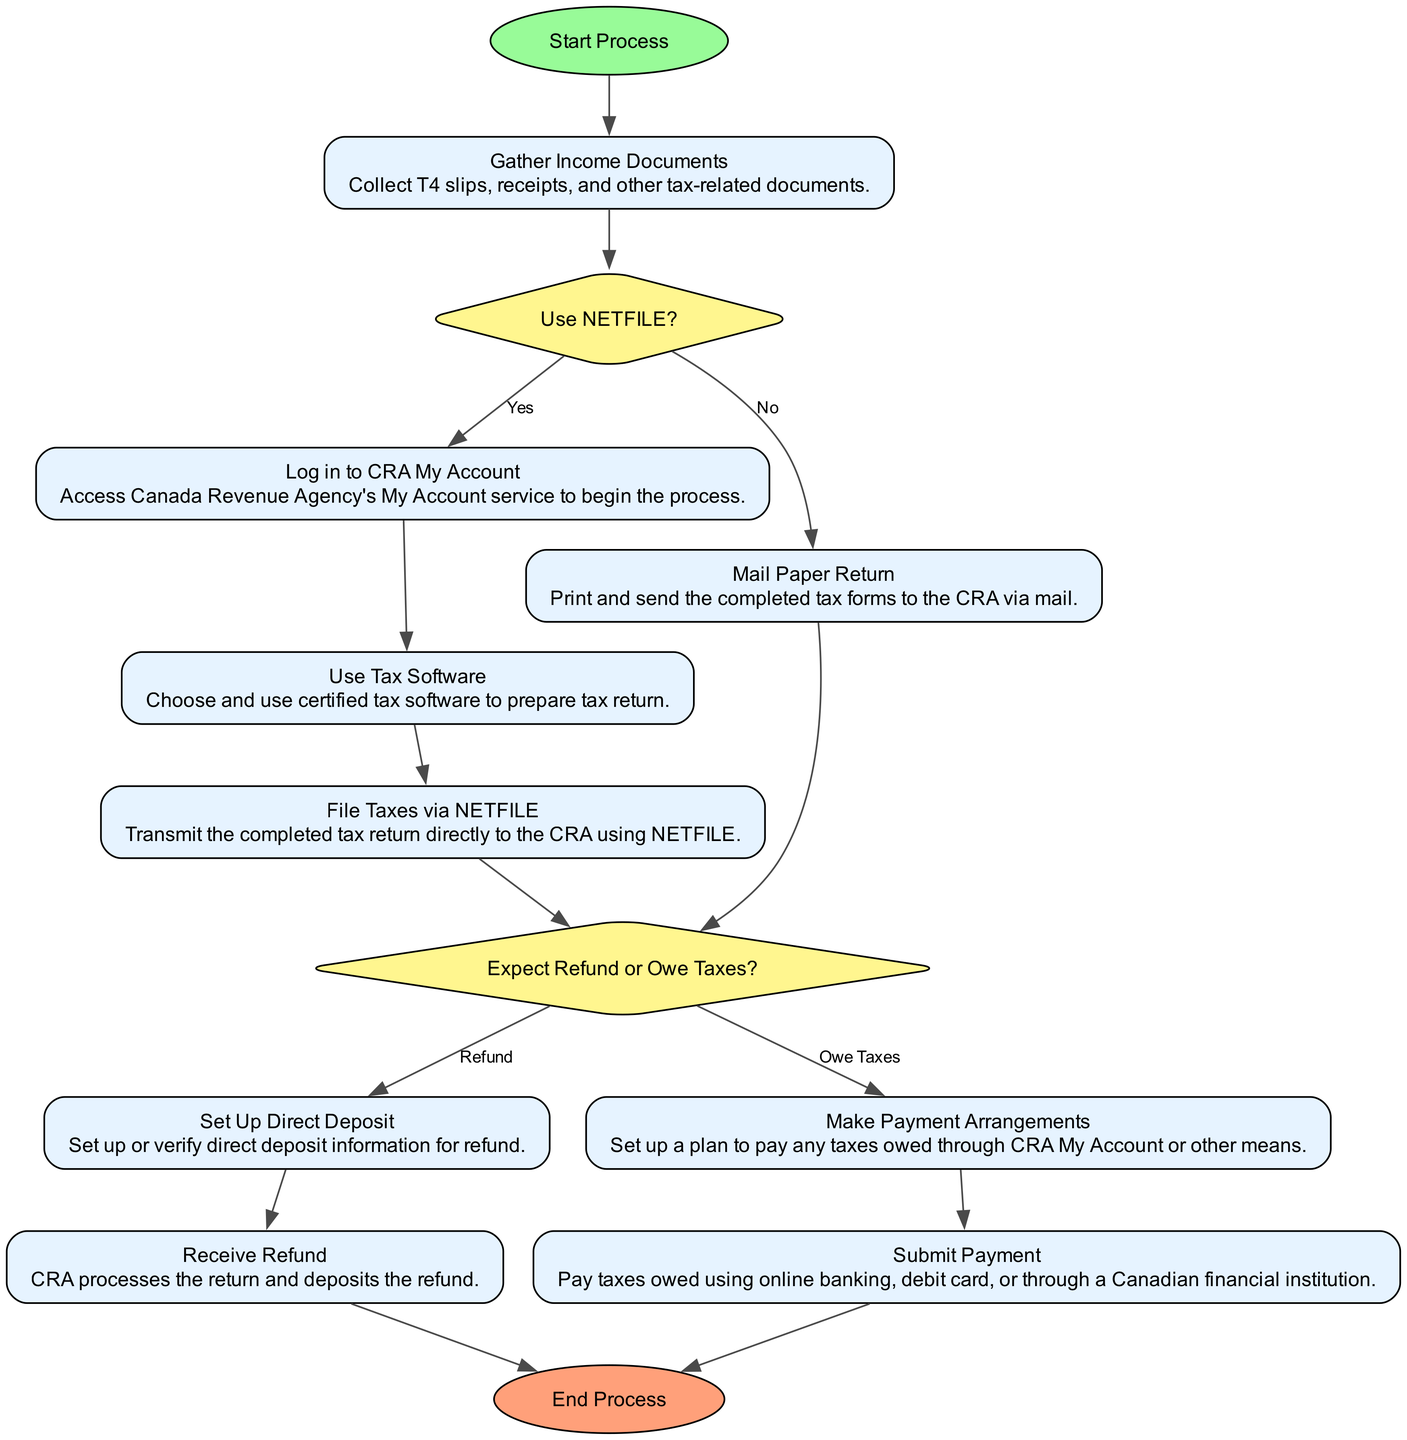What is the first activity in the process? The first activity, indicated right after the start, is "Gather Income Documents." This is the initial step required to begin filing taxes online.
Answer: Gather Income Documents How many decision nodes are present in the diagram? The diagram contains two decision nodes: "Use NETFILE?" and "Expect Refund or Owe Taxes?". Both are key decision points in the tax filing process.
Answer: 2 What action is taken if the answer to "Use NETFILE?" is "No"? If "Use NETFILE?" is answered with "No", the next action is "Mail Paper Return," which indicates that the taxpayer will mail their tax forms instead of filing online.
Answer: Mail Paper Return Which activity follows after logging into CRA My Account? After "Log in to CRA My Account," the subsequent activity is "Use Tax Software," where the taxpayer prepares their tax return using certified tax software.
Answer: Use Tax Software What is the outcome if taxes owed is indicated as "Refund"? If taxes owed is indicated as "Refund," the process moves to "Set Up Direct Deposit," where the taxpayer sets up or confirms their direct deposit information for receiving the refund.
Answer: Set Up Direct Deposit Which activity leads directly to the end of the process after receiving a refund? After "Receive Refund," the next step is directly connected to "End Process," completing the filing and payment cycle for income taxes.
Answer: End Process What is the final step for making payments if taxes are owed? If it is established that the taxpayer owes taxes, the final step for making payments is "Submit Payment," where the taxpayer pays any outstanding taxes due.
Answer: Submit Payment What type of software must be used for preparing the tax return? The diagram specifies that one must use "certified tax software" to prepare the tax return to ensure compliance and correctness in the submission.
Answer: Certified tax software Which node indicates the choice between receiving a refund or owing taxes? The node that indicates the choice between receiving a refund or owing taxes is "Expect Refund or Owe Taxes?" It assesses the tax return outcome and directs the next steps based on this decision.
Answer: Expect Refund or Owe Taxes? 